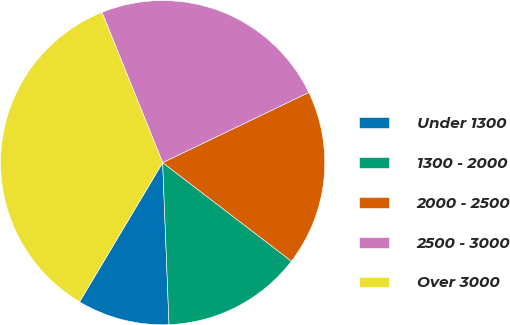Convert chart to OTSL. <chart><loc_0><loc_0><loc_500><loc_500><pie_chart><fcel>Under 1300<fcel>1300 - 2000<fcel>2000 - 2500<fcel>2500 - 3000<fcel>Over 3000<nl><fcel>9.19%<fcel>13.98%<fcel>17.52%<fcel>23.98%<fcel>35.33%<nl></chart> 